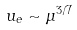Convert formula to latex. <formula><loc_0><loc_0><loc_500><loc_500>u _ { e } \sim \mu ^ { 3 / 7 }</formula> 